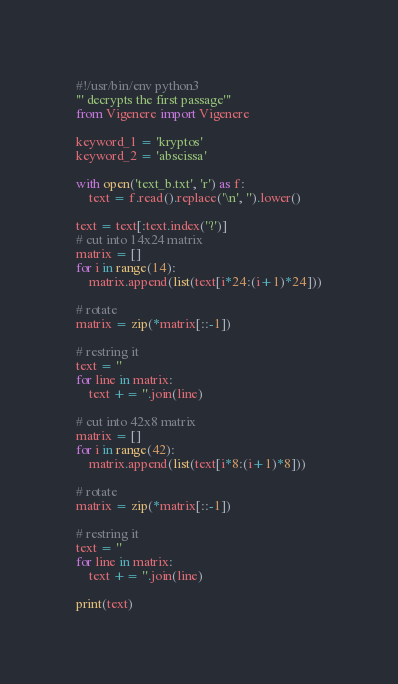<code> <loc_0><loc_0><loc_500><loc_500><_Python_>#!/usr/bin/env python3
''' decrypts the first passage'''
from Vigenere import Vigenere

keyword_1 = 'kryptos'
keyword_2 = 'abscissa'

with open('text_b.txt', 'r') as f:
    text = f.read().replace('\n', '').lower()

text = text[:text.index('?')]
# cut into 14x24 matrix
matrix = []
for i in range(14):
    matrix.append(list(text[i*24:(i+1)*24]))

# rotate
matrix = zip(*matrix[::-1])

# restring it
text = ''
for line in matrix:
    text += ''.join(line)

# cut into 42x8 matrix
matrix = []
for i in range(42):
    matrix.append(list(text[i*8:(i+1)*8]))

# rotate
matrix = zip(*matrix[::-1])

# restring it
text = ''
for line in matrix:
    text += ''.join(line)

print(text)
</code> 